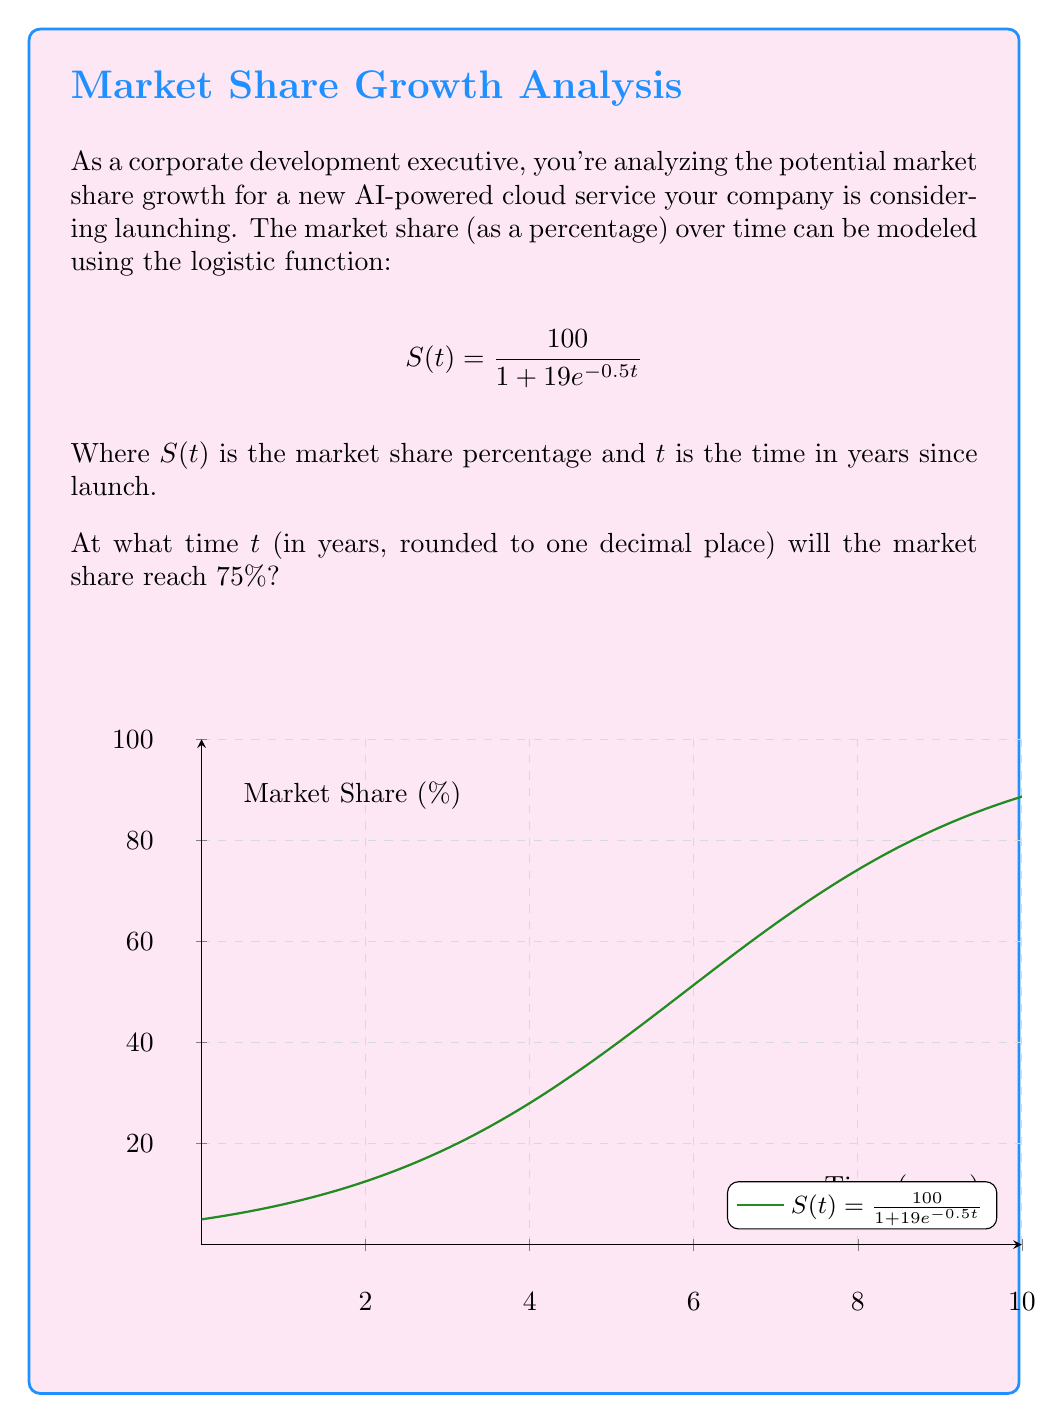Could you help me with this problem? To solve this problem, we need to follow these steps:

1) We want to find $t$ when $S(t) = 75$. So, let's set up the equation:

   $$ 75 = \frac{100}{1 + 19e^{-0.5t}} $$

2) Multiply both sides by $(1 + 19e^{-0.5t})$:

   $$ 75(1 + 19e^{-0.5t}) = 100 $$

3) Expand the left side:

   $$ 75 + 1425e^{-0.5t} = 100 $$

4) Subtract 75 from both sides:

   $$ 1425e^{-0.5t} = 25 $$

5) Divide both sides by 1425:

   $$ e^{-0.5t} = \frac{25}{1425} = \frac{1}{57} $$

6) Take the natural log of both sides:

   $$ -0.5t = \ln(\frac{1}{57}) $$

7) Multiply both sides by -2:

   $$ t = -2\ln(\frac{1}{57}) = 2\ln(57) $$

8) Calculate and round to one decimal place:

   $$ t \approx 8.2 $$

Therefore, the market share will reach 75% after approximately 8.2 years.
Answer: 8.2 years 